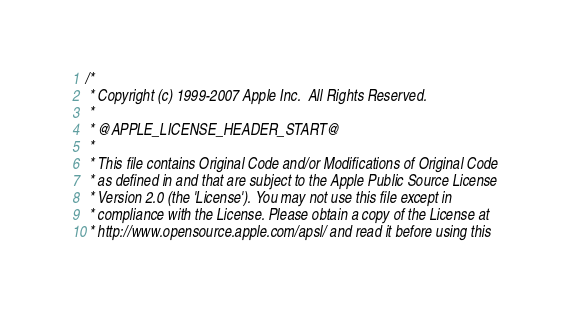Convert code to text. <code><loc_0><loc_0><loc_500><loc_500><_ObjectiveC_>/*
 * Copyright (c) 1999-2007 Apple Inc.  All Rights Reserved.
 * 
 * @APPLE_LICENSE_HEADER_START@
 * 
 * This file contains Original Code and/or Modifications of Original Code
 * as defined in and that are subject to the Apple Public Source License
 * Version 2.0 (the 'License'). You may not use this file except in
 * compliance with the License. Please obtain a copy of the License at
 * http://www.opensource.apple.com/apsl/ and read it before using this</code> 